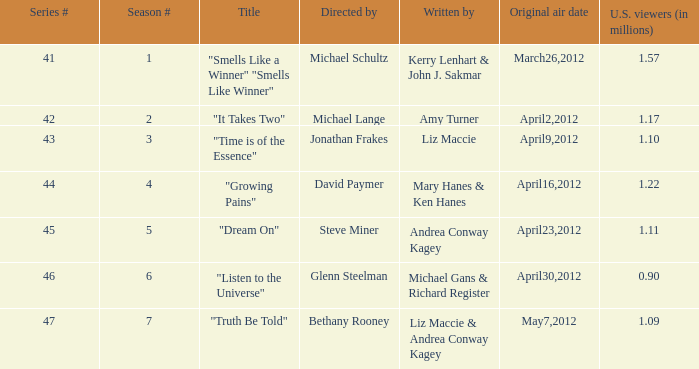How many millions of viewers did the episode written by Andrea Conway Kagey? 1.11. 